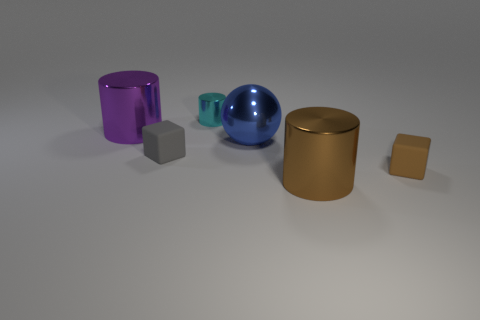Add 1 blue objects. How many objects exist? 7 Subtract all big brown cylinders. How many cylinders are left? 2 Subtract all cubes. How many objects are left? 4 Subtract all blue cylinders. Subtract all yellow spheres. How many cylinders are left? 3 Subtract 0 yellow spheres. How many objects are left? 6 Subtract all small brown blocks. Subtract all tiny gray things. How many objects are left? 4 Add 6 rubber blocks. How many rubber blocks are left? 8 Add 1 rubber cubes. How many rubber cubes exist? 3 